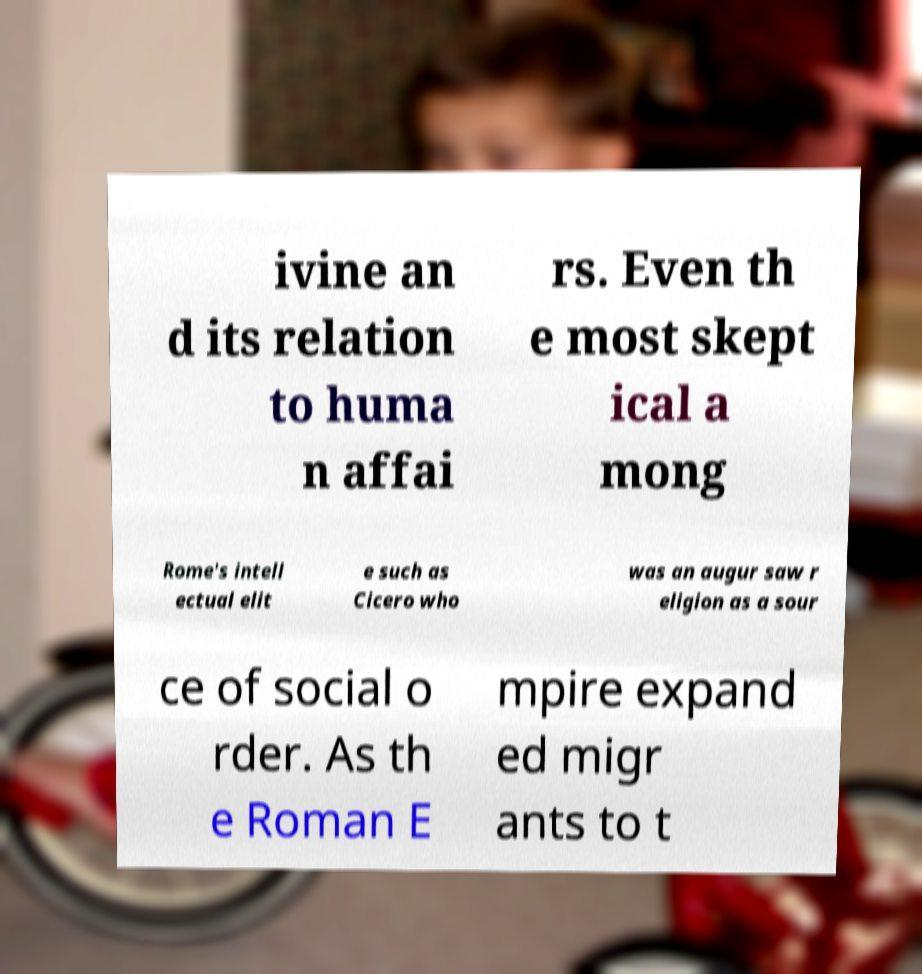What messages or text are displayed in this image? I need them in a readable, typed format. ivine an d its relation to huma n affai rs. Even th e most skept ical a mong Rome's intell ectual elit e such as Cicero who was an augur saw r eligion as a sour ce of social o rder. As th e Roman E mpire expand ed migr ants to t 